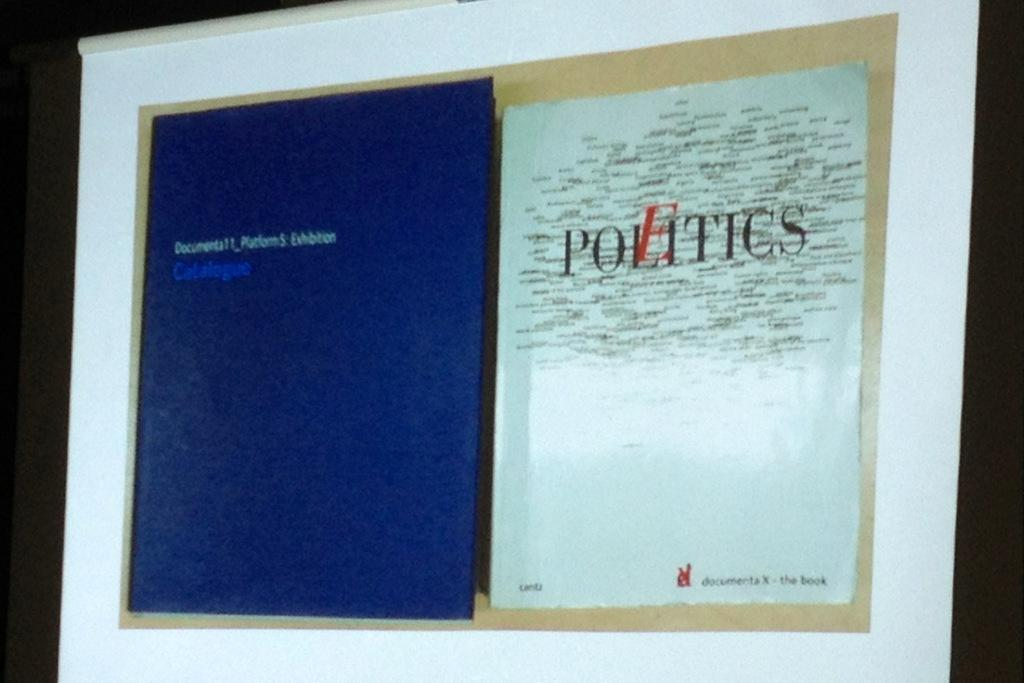Provide a one-sentence caption for the provided image. A blue and a white poster on a wall, the white one reading Politics. 